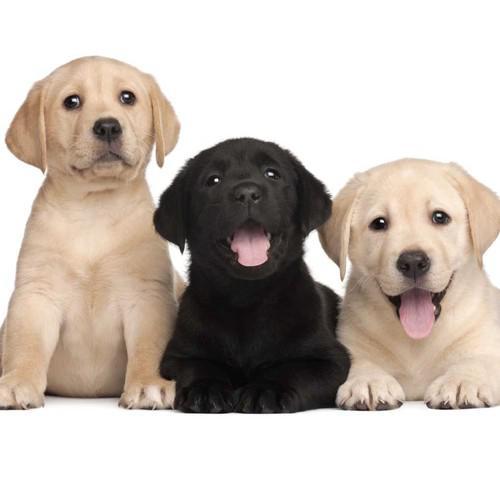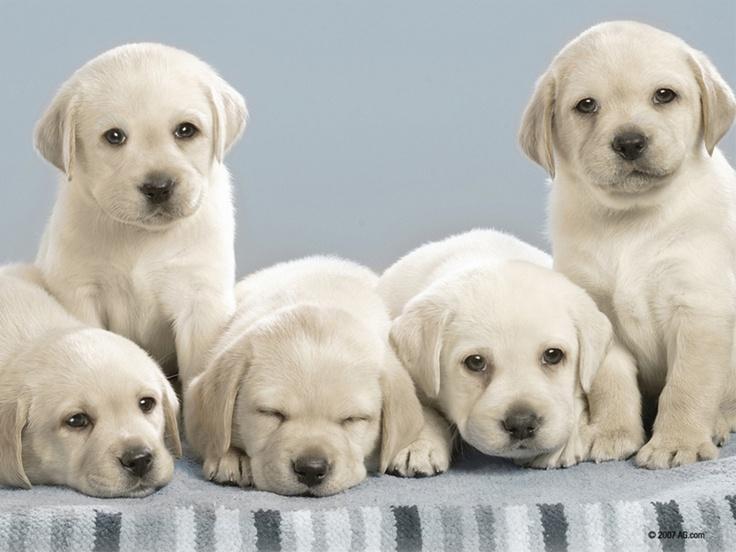The first image is the image on the left, the second image is the image on the right. Assess this claim about the two images: "The left image shows a total of 3 dogs". Correct or not? Answer yes or no. Yes. The first image is the image on the left, the second image is the image on the right. Examine the images to the left and right. Is the description "there are exactly three animals in the image on the left" accurate? Answer yes or no. Yes. 